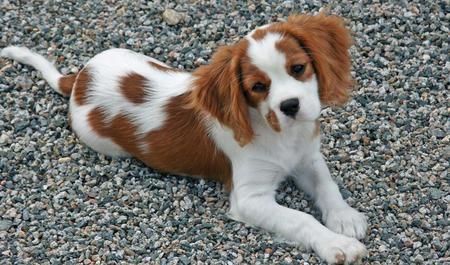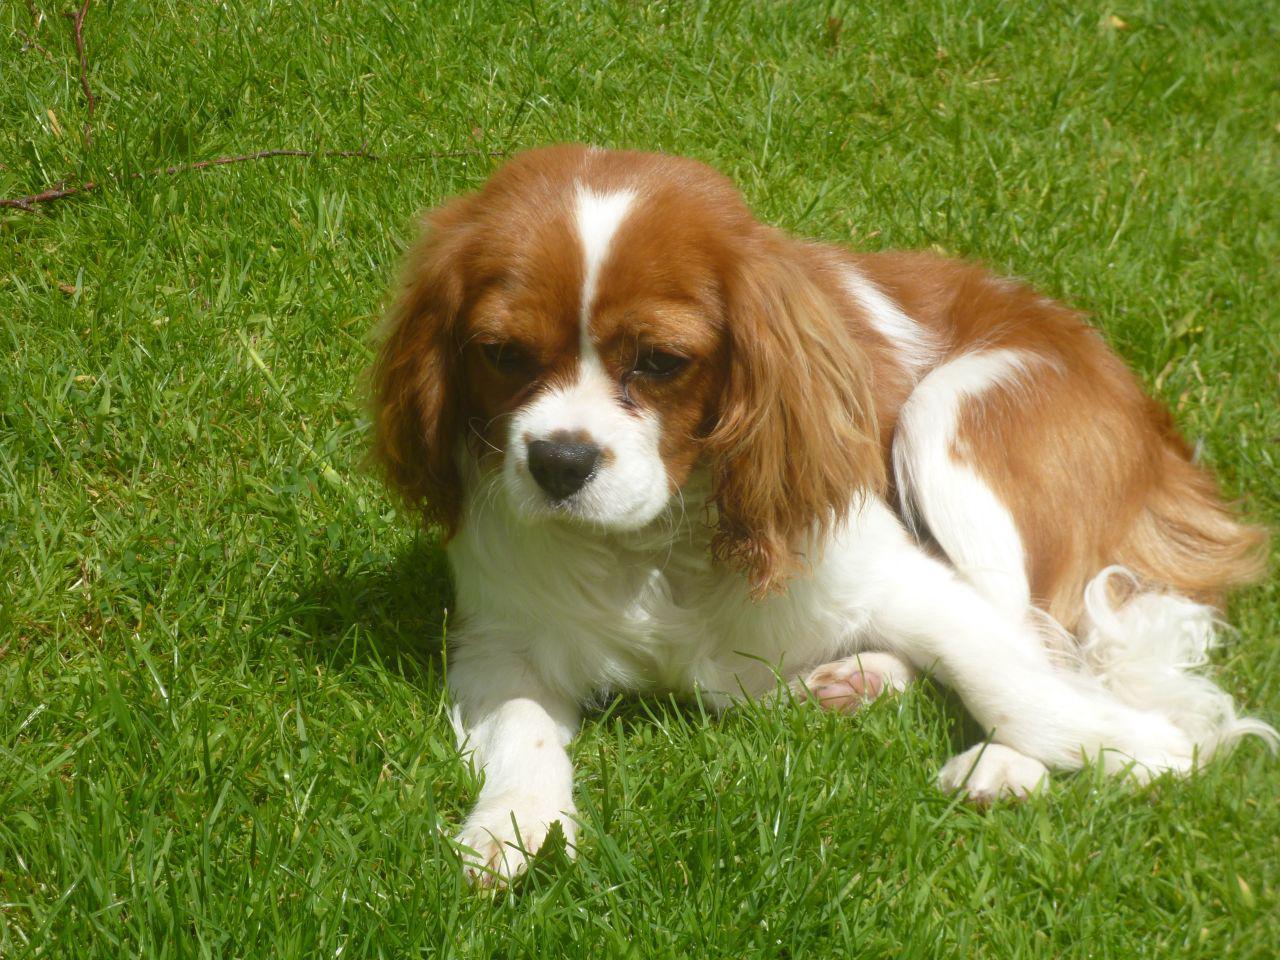The first image is the image on the left, the second image is the image on the right. Considering the images on both sides, is "An image shows one tan-and-white spaniel reclining directly on green grass." valid? Answer yes or no. Yes. The first image is the image on the left, the second image is the image on the right. For the images displayed, is the sentence "One of the images contain one dog lying on grass." factually correct? Answer yes or no. Yes. 